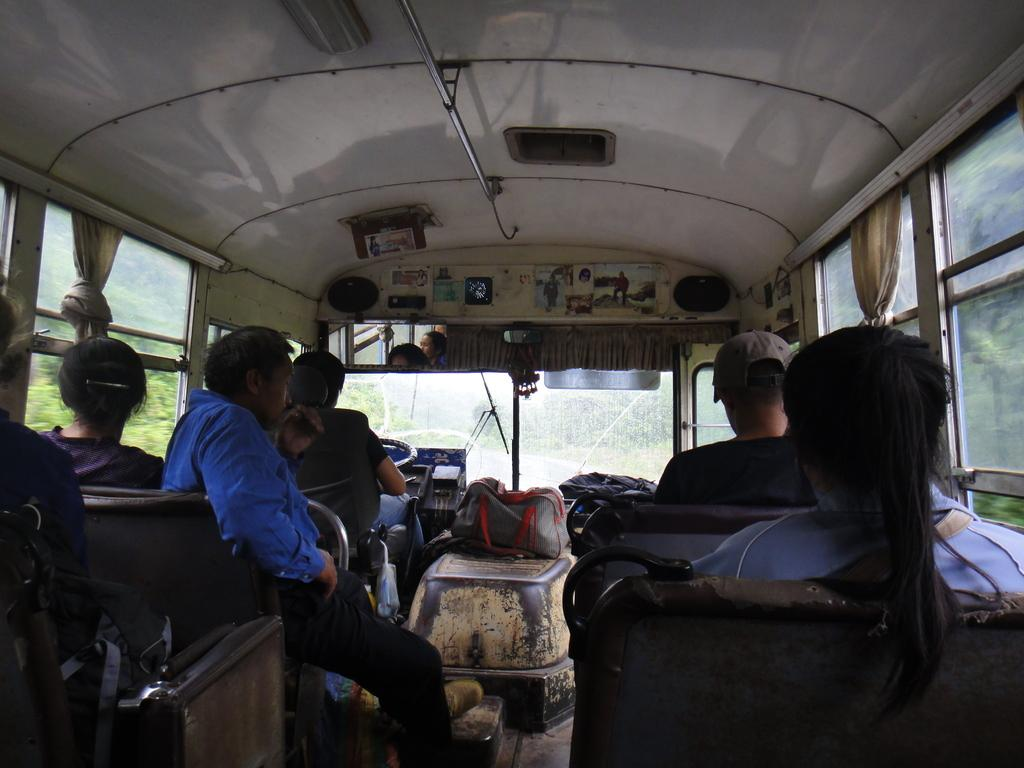Who or what can be seen in the image? There are people in the image. What objects are present with the people? There are bags in the image. Where are the people located? The people are sitting in a vehicle. What can be seen in the distance in the image? There are trees visible in the background of the image. What type of cloth is being used to cover the coal in the image? There is no cloth or coal present in the image. 